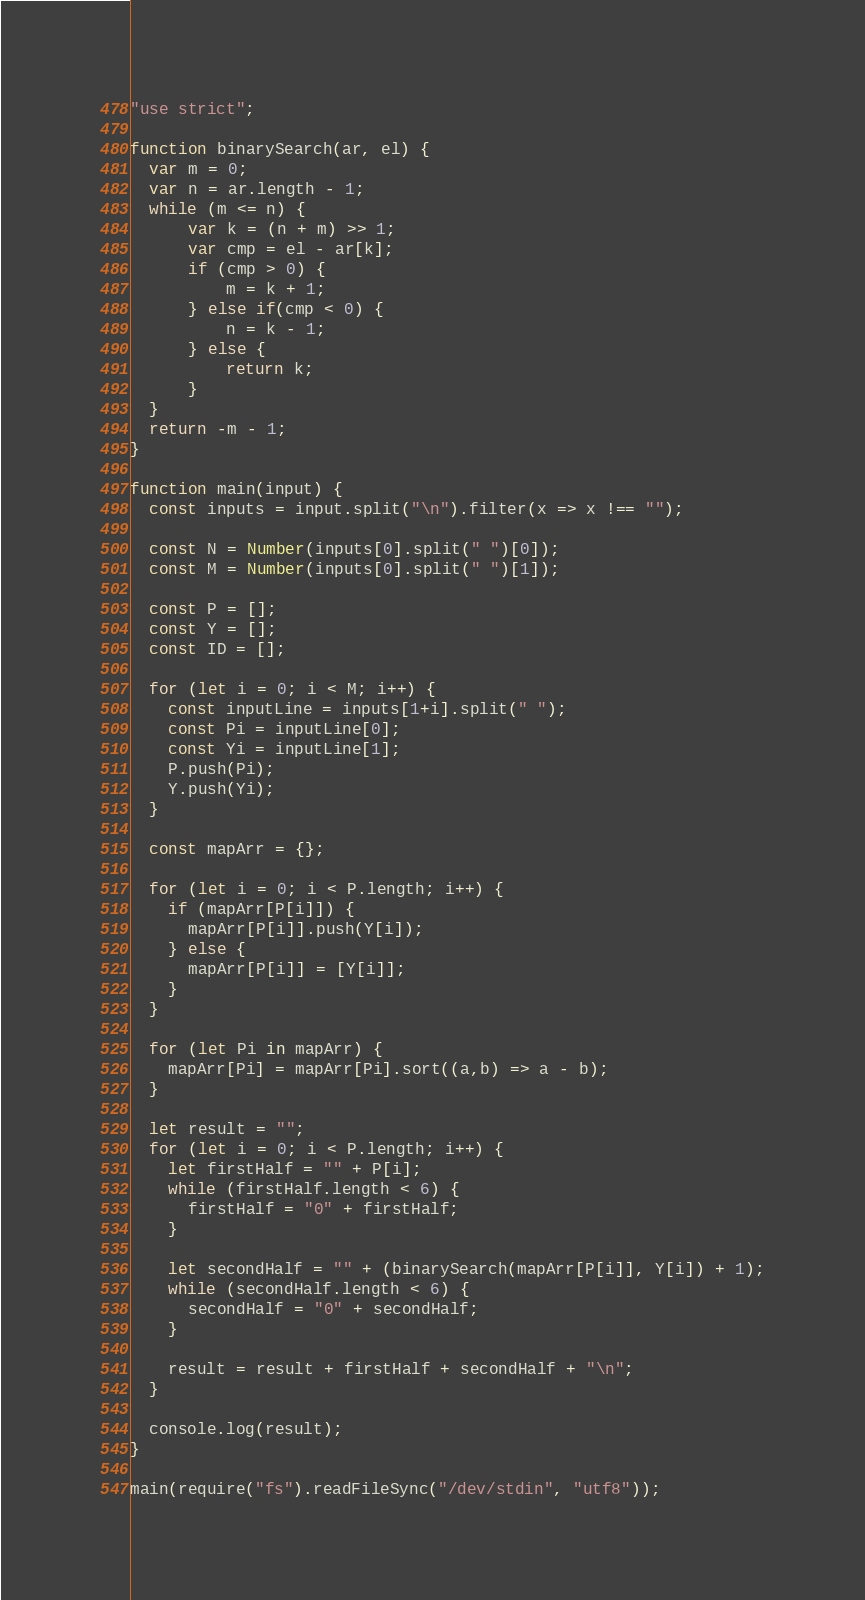Convert code to text. <code><loc_0><loc_0><loc_500><loc_500><_JavaScript_>"use strict";

function binarySearch(ar, el) {
  var m = 0;
  var n = ar.length - 1;
  while (m <= n) {
      var k = (n + m) >> 1;
      var cmp = el - ar[k];
      if (cmp > 0) {
          m = k + 1;
      } else if(cmp < 0) {
          n = k - 1;
      } else {
          return k;
      }
  }
  return -m - 1;
}

function main(input) {
  const inputs = input.split("\n").filter(x => x !== "");

  const N = Number(inputs[0].split(" ")[0]);
  const M = Number(inputs[0].split(" ")[1]);
  
  const P = [];
  const Y = [];
  const ID = [];

  for (let i = 0; i < M; i++) {
    const inputLine = inputs[1+i].split(" ");
    const Pi = inputLine[0];
    const Yi = inputLine[1];
    P.push(Pi);
    Y.push(Yi);
  }

  const mapArr = {};

  for (let i = 0; i < P.length; i++) {
    if (mapArr[P[i]]) {
      mapArr[P[i]].push(Y[i]);
    } else {
      mapArr[P[i]] = [Y[i]];
    }
  }

  for (let Pi in mapArr) {
    mapArr[Pi] = mapArr[Pi].sort((a,b) => a - b);
  }

  let result = "";
  for (let i = 0; i < P.length; i++) {
    let firstHalf = "" + P[i];
    while (firstHalf.length < 6) {
      firstHalf = "0" + firstHalf;
    }

    let secondHalf = "" + (binarySearch(mapArr[P[i]], Y[i]) + 1);
    while (secondHalf.length < 6) {
      secondHalf = "0" + secondHalf;
    }

    result = result + firstHalf + secondHalf + "\n";
  }

  console.log(result);
}

main(require("fs").readFileSync("/dev/stdin", "utf8"));
</code> 